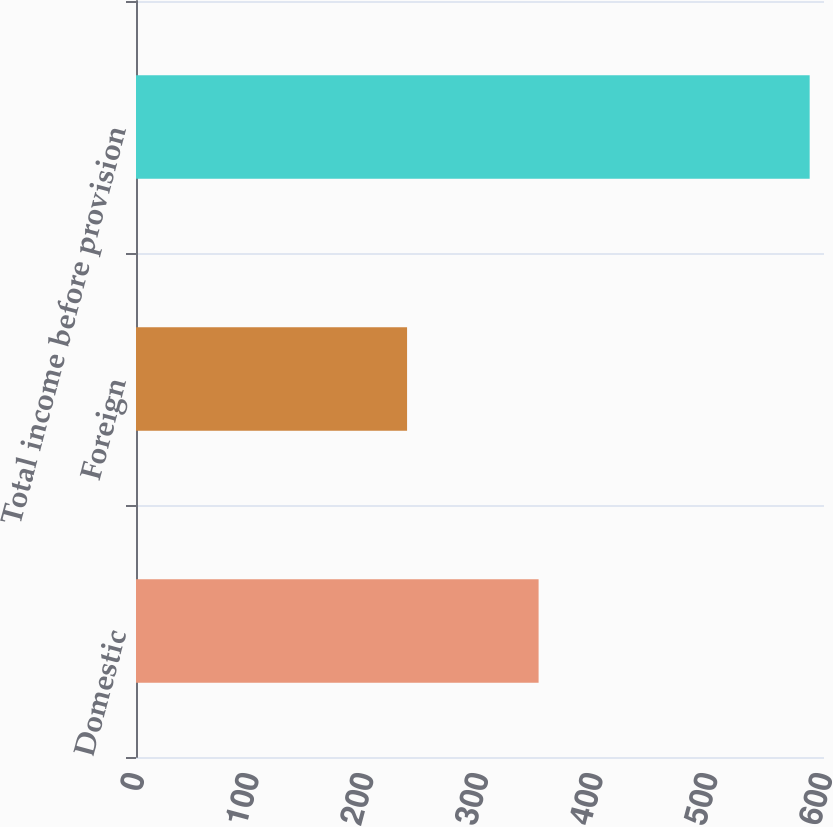Convert chart to OTSL. <chart><loc_0><loc_0><loc_500><loc_500><bar_chart><fcel>Domestic<fcel>Foreign<fcel>Total income before provision<nl><fcel>351.1<fcel>236.4<fcel>587.5<nl></chart> 